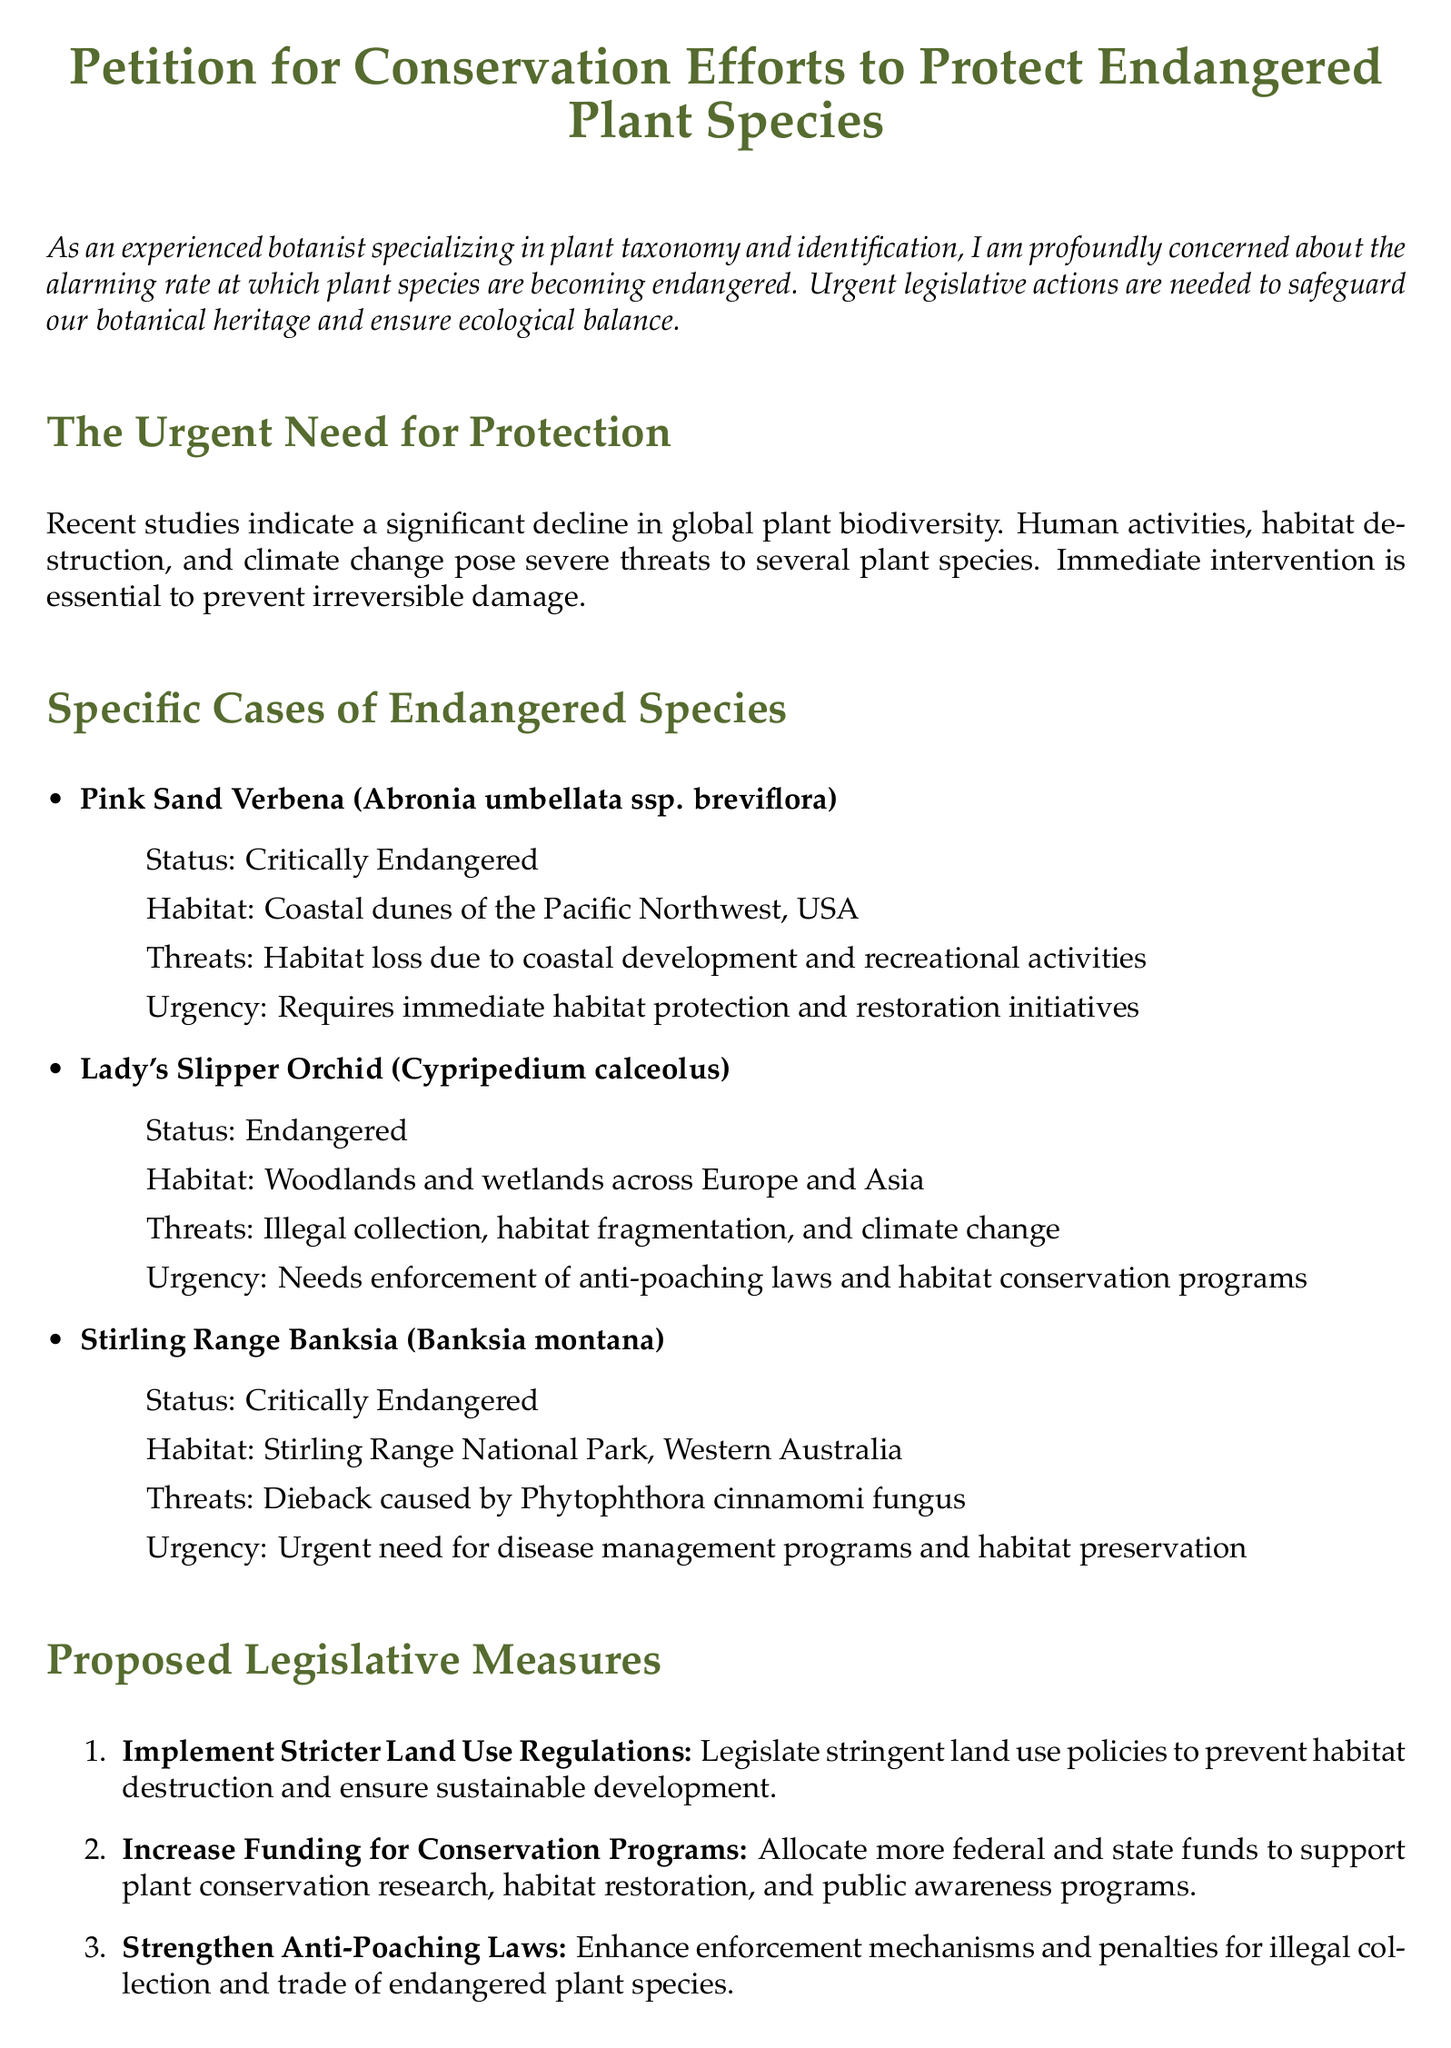what is the title of the document? The title is a clear indication of the document's purpose, which addresses conservation efforts.
Answer: Petition for Conservation Efforts to Protect Endangered Plant Species how many endangered plant species are specifically mentioned? The document lists three specific examples of at-risk flora.
Answer: three what is the status of Pink Sand Verbena? The status indicates how at-risk the species is, which reflects its conservation needs.
Answer: Critically Endangered which habitat does the Lady's Slipper Orchid inhabit? The habitat provides important context for understanding the species' ecosystem requirements.
Answer: Woodlands and wetlands across Europe and Asia what is one proposed legislative measure to support plant conservation? This question focuses on actionable steps that could be taken to improve conservation efforts.
Answer: Implement Stricter Land Use Regulations what is the main threat to the Stirling Range Banksia? Identifying threats helps in prioritizing conservation strategies for specific species.
Answer: Dieback caused by Phytophthora cinnamomi fungus what year is the document emphasizing the urgent need for protection? The document highlights a pressing contemporary issue within a clearly articulated timeframe or context.
Answer: 2023 what is the signature line length in the petition? This detail reveals formatting choices that support the signature process in the petition.
Answer: 5 cm 